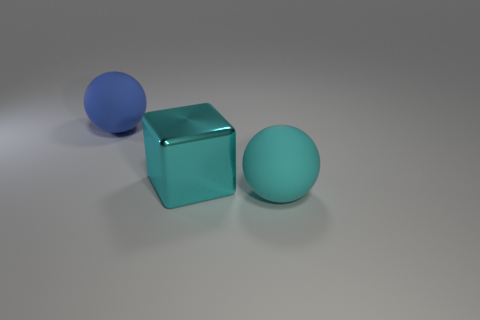Add 3 big matte balls. How many objects exist? 6 Subtract all spheres. How many objects are left? 1 Add 1 cyan cubes. How many cyan cubes are left? 2 Add 2 large blue balls. How many large blue balls exist? 3 Subtract 0 purple balls. How many objects are left? 3 Subtract all small purple shiny things. Subtract all rubber balls. How many objects are left? 1 